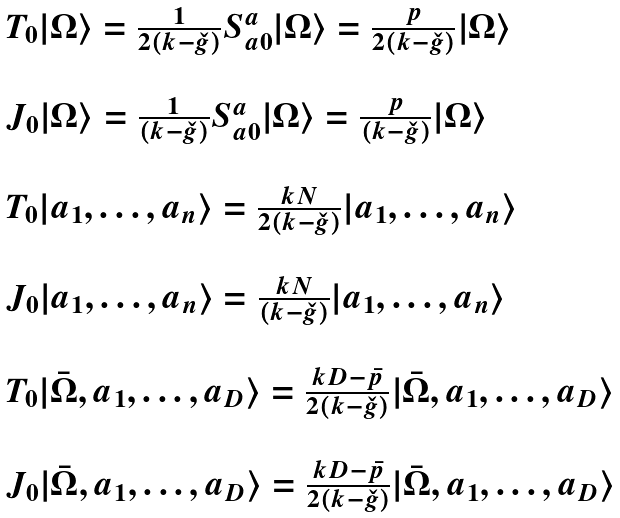Convert formula to latex. <formula><loc_0><loc_0><loc_500><loc_500>\begin{array} { l } { { T _ { 0 } | \Omega \rangle = \frac { 1 } { 2 ( k - \check { g } ) } S _ { a 0 } ^ { a } | \Omega \rangle = \frac { p } { 2 ( k - \check { g } ) } | \Omega \rangle } } \\ { \ } \\ { { J _ { 0 } | \Omega \rangle = \frac { 1 } { ( k - \check { g } ) } S _ { a 0 } ^ { a } | \Omega \rangle = \frac { p } { ( k - \check { g } ) } | \Omega \rangle } } \\ { \ } \\ { { T _ { 0 } | a _ { 1 } , \dots , a _ { n } \rangle = \frac { k N } { 2 ( k - \check { g } ) } | a _ { 1 } , \dots , a _ { n } \rangle } } \\ { \ } \\ { { J _ { 0 } | a _ { 1 } , \dots , a _ { n } \rangle = \frac { k N } { ( k - \check { g } ) } | a _ { 1 } , \dots , a _ { n } \rangle } } \\ { \ } \\ { { T _ { 0 } | \bar { \Omega } , a _ { 1 } , \dots , a _ { D } \rangle = \frac { k D - \bar { p } } { 2 ( k - \check { g } ) } | \bar { \Omega } , a _ { 1 } , \dots , a _ { D } \rangle } } \\ { \ } \\ { { J _ { 0 } | \bar { \Omega } , a _ { 1 } , \dots , a _ { D } \rangle = \frac { k D - \bar { p } } { 2 ( k - \check { g } ) } | \bar { \Omega } , a _ { 1 } , \dots , a _ { D } \rangle } } \end{array}</formula> 